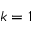<formula> <loc_0><loc_0><loc_500><loc_500>k = 1</formula> 